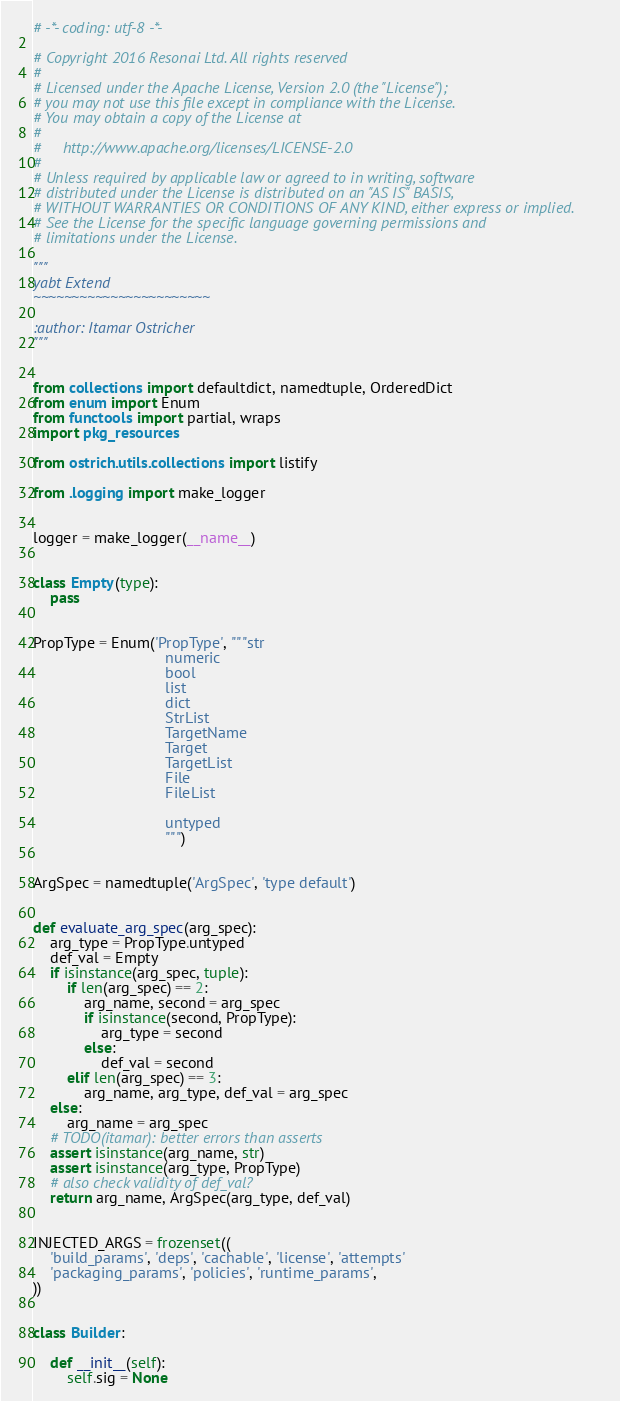Convert code to text. <code><loc_0><loc_0><loc_500><loc_500><_Python_># -*- coding: utf-8 -*-

# Copyright 2016 Resonai Ltd. All rights reserved
#
# Licensed under the Apache License, Version 2.0 (the "License");
# you may not use this file except in compliance with the License.
# You may obtain a copy of the License at
#
#     http://www.apache.org/licenses/LICENSE-2.0
#
# Unless required by applicable law or agreed to in writing, software
# distributed under the License is distributed on an "AS IS" BASIS,
# WITHOUT WARRANTIES OR CONDITIONS OF ANY KIND, either express or implied.
# See the License for the specific language governing permissions and
# limitations under the License.

"""
yabt Extend
~~~~~~~~~~~~~~~~~~~~~~~

:author: Itamar Ostricher
"""


from collections import defaultdict, namedtuple, OrderedDict
from enum import Enum
from functools import partial, wraps
import pkg_resources

from ostrich.utils.collections import listify

from .logging import make_logger


logger = make_logger(__name__)


class Empty(type):
    pass


PropType = Enum('PropType', """str
                               numeric
                               bool
                               list
                               dict
                               StrList
                               TargetName
                               Target
                               TargetList
                               File
                               FileList

                               untyped
                               """)


ArgSpec = namedtuple('ArgSpec', 'type default')


def evaluate_arg_spec(arg_spec):
    arg_type = PropType.untyped
    def_val = Empty
    if isinstance(arg_spec, tuple):
        if len(arg_spec) == 2:
            arg_name, second = arg_spec
            if isinstance(second, PropType):
                arg_type = second
            else:
                def_val = second
        elif len(arg_spec) == 3:
            arg_name, arg_type, def_val = arg_spec
    else:
        arg_name = arg_spec
    # TODO(itamar): better errors than asserts
    assert isinstance(arg_name, str)
    assert isinstance(arg_type, PropType)
    # also check validity of def_val?
    return arg_name, ArgSpec(arg_type, def_val)


INJECTED_ARGS = frozenset((
    'build_params', 'deps', 'cachable', 'license', 'attempts'
    'packaging_params', 'policies', 'runtime_params',
))


class Builder:

    def __init__(self):
        self.sig = None</code> 